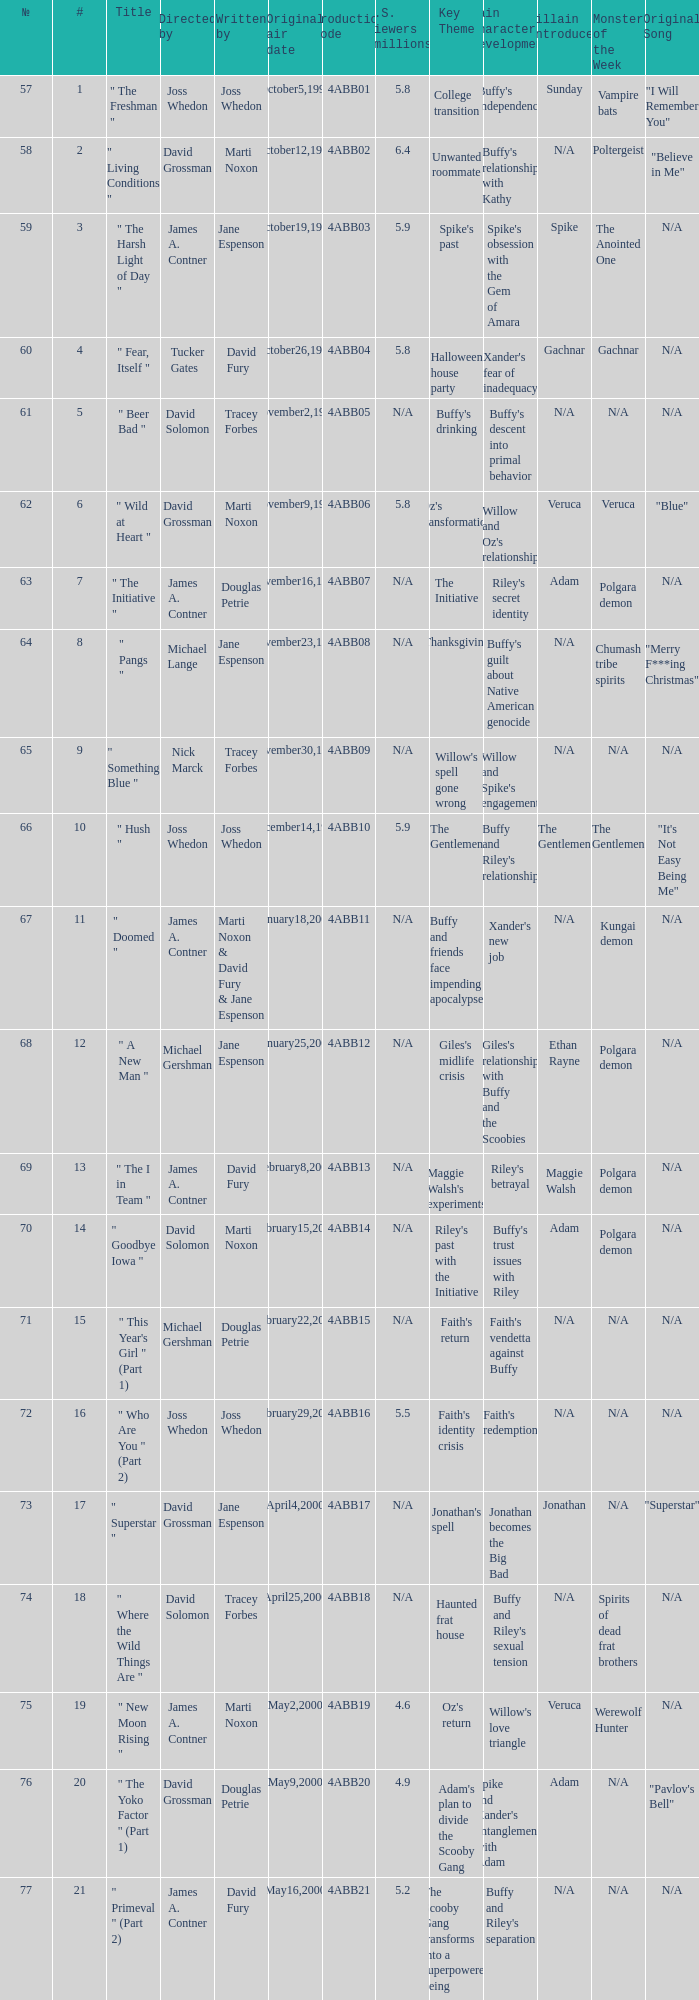What is the series No when the season 4 # is 18? 74.0. 